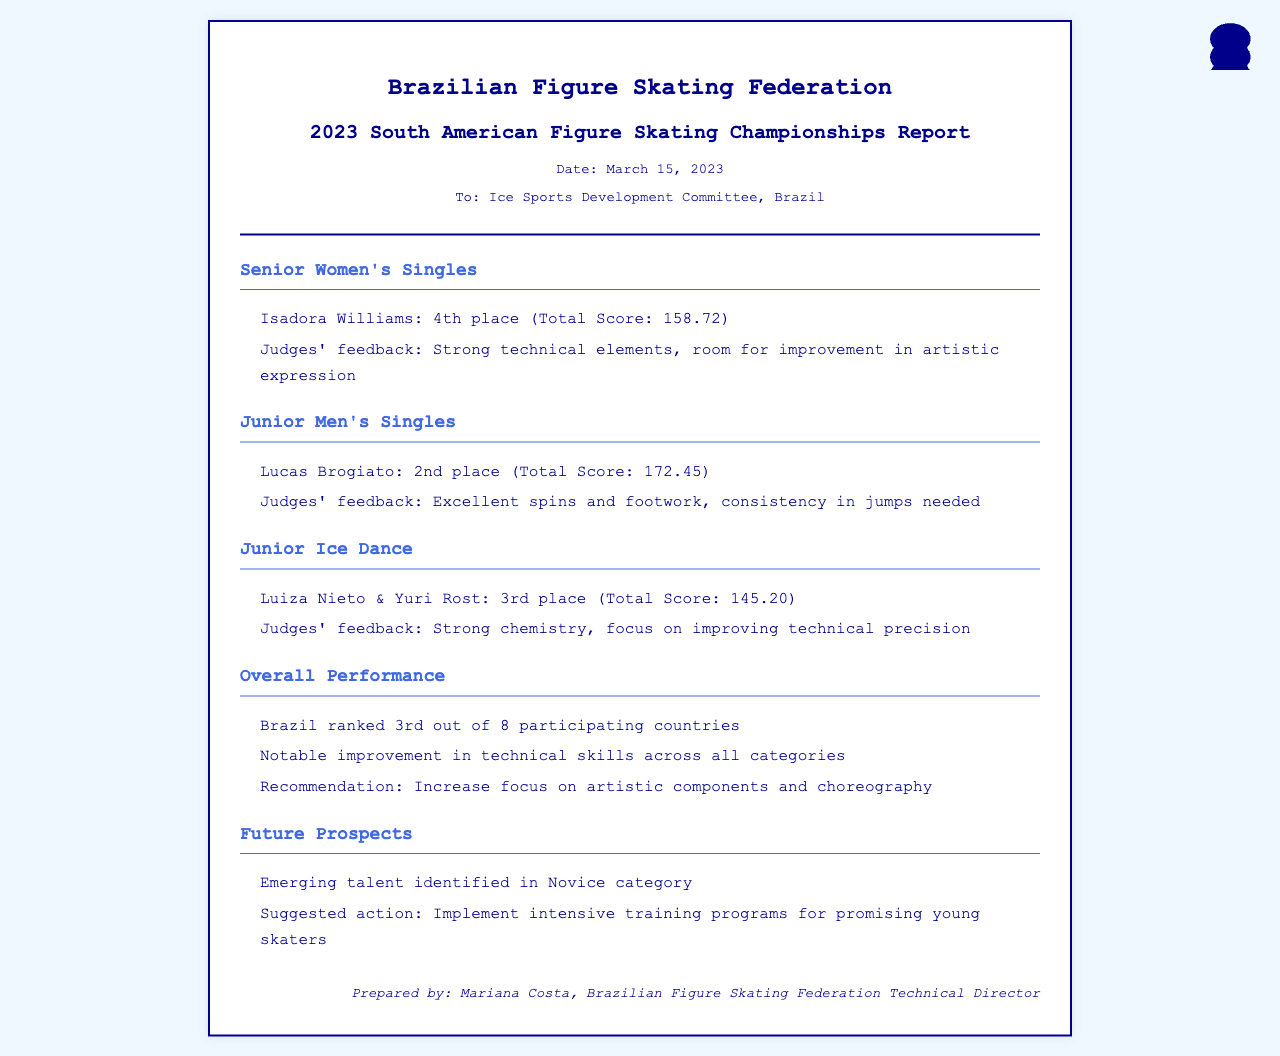What was Isadora Williams' placement? Isadora Williams achieved 4th place in the Senior Women's Singles category at the championships.
Answer: 4th place What was Lucas Brogiato's total score? Lucas Brogiato scored a total of 172.45 points in the Junior Men's Singles category.
Answer: 172.45 What feedback did the judges give to Luiza Nieto & Yuri Rost? The judges noted that Luiza Nieto & Yuri Rost had strong chemistry but needed to improve their technical precision.
Answer: Improve technical precision What rank did Brazil achieve overall? Brazil ranked 3rd out of 8 participating countries at the championships.
Answer: 3rd What was a notable improvement mentioned in the report? The report highlighted a notable improvement in technical skills across all categories for Brazilian skaters.
Answer: Technical skills Who prepared the report? The report was prepared by Mariana Costa, the Technical Director of the Brazilian Figure Skating Federation.
Answer: Mariana Costa What is a suggested action for the emerging talent? The document suggests implementing intensive training programs for promising young skaters identified in the Novice category.
Answer: Intensive training programs What specific characteristic needs more focus according to the overall performance section? The overall performance section recommends increasing focus on artistic components and choreography.
Answer: Artistic components and choreography 